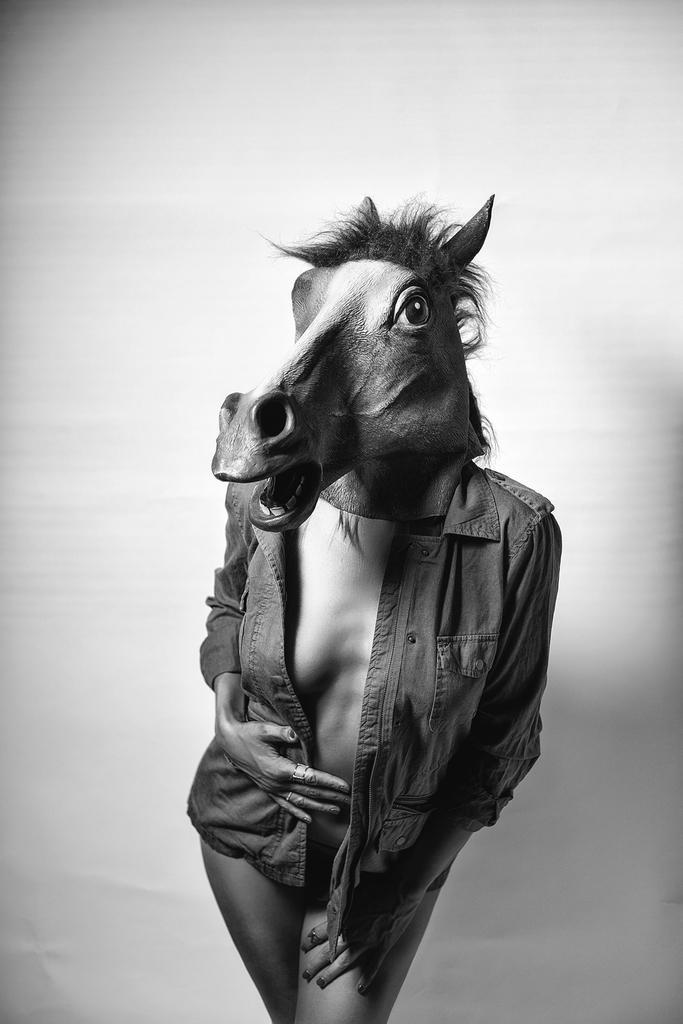Please provide a concise description of this image. As we can see in the image, the person is wearing a jacket and animal mask over head. According to me the person's attire is inappropriate. 